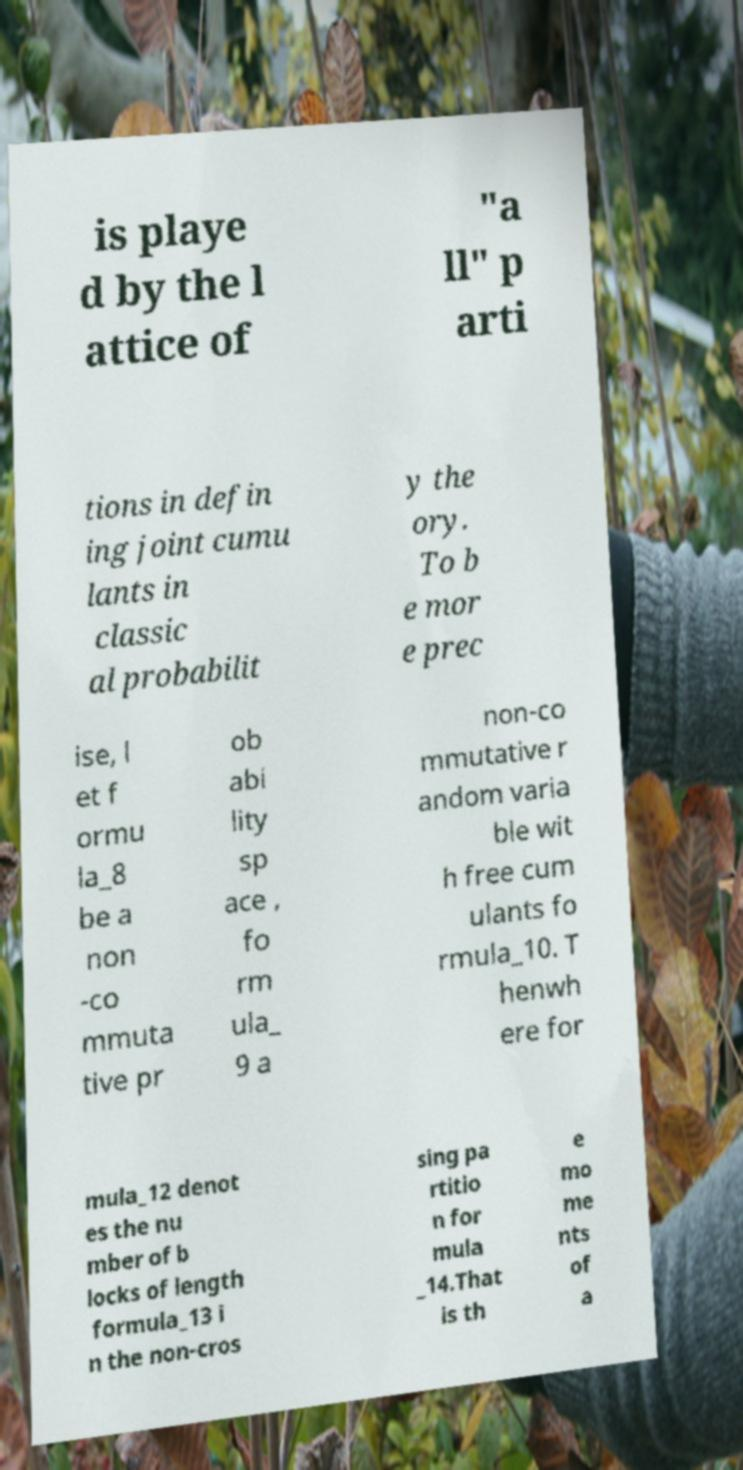Could you assist in decoding the text presented in this image and type it out clearly? is playe d by the l attice of "a ll" p arti tions in defin ing joint cumu lants in classic al probabilit y the ory. To b e mor e prec ise, l et f ormu la_8 be a non -co mmuta tive pr ob abi lity sp ace , fo rm ula_ 9 a non-co mmutative r andom varia ble wit h free cum ulants fo rmula_10. T henwh ere for mula_12 denot es the nu mber of b locks of length formula_13 i n the non-cros sing pa rtitio n for mula _14.That is th e mo me nts of a 